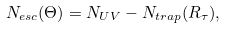Convert formula to latex. <formula><loc_0><loc_0><loc_500><loc_500>N _ { e s c } ( \Theta ) = N _ { U V } - N _ { t r a p } ( R _ { \tau } ) ,</formula> 